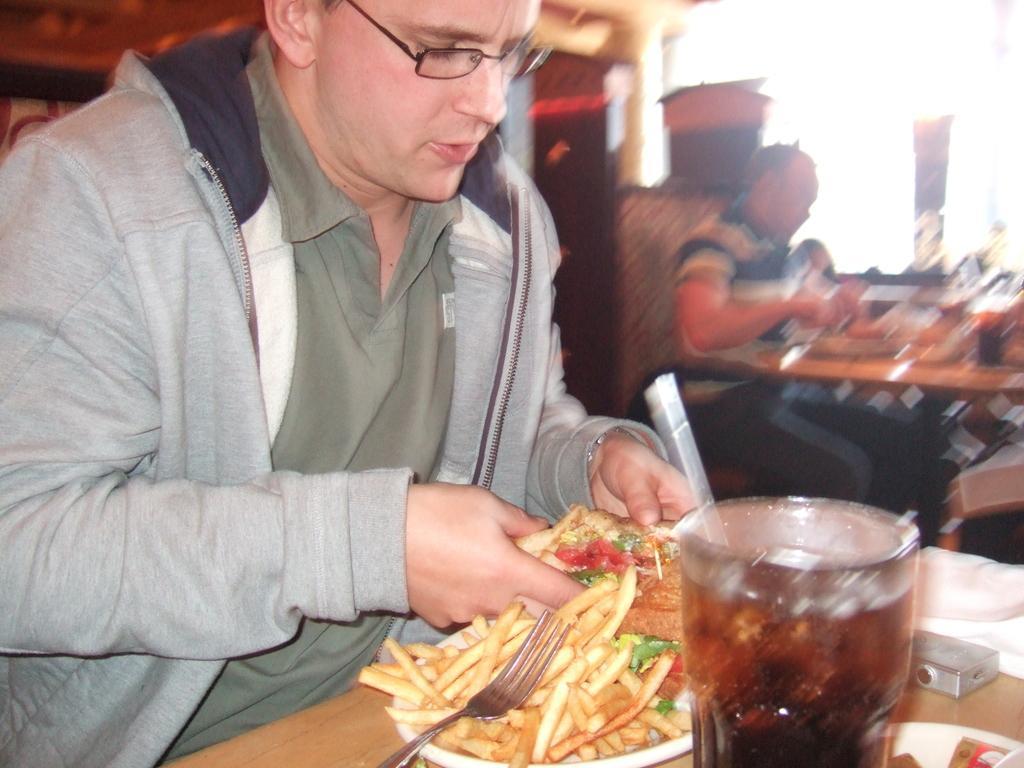Describe this image in one or two sentences. This picture is clicked inside. On the left we can see the two persons wearing t-shirts, sitting on the chairs and seems to be eating. On the right we can see the tables on the top of which glass of drink, platter containing food item, fork and some other items are placed. In the background we can see some other objects. 